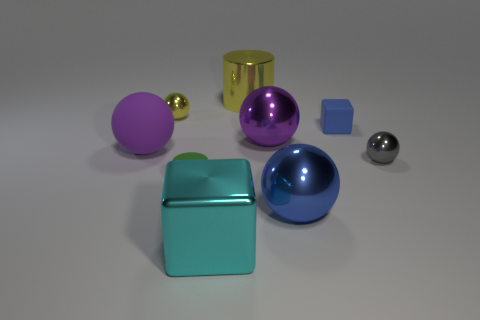There is a small ball that is in front of the purple thing right of the large yellow object; what is its color?
Provide a short and direct response. Gray. Is the number of matte cylinders behind the gray metallic object less than the number of large purple things that are to the right of the tiny green thing?
Offer a terse response. Yes. There is a blue block; is its size the same as the gray sphere that is behind the blue metallic sphere?
Provide a succinct answer. Yes. What is the shape of the metallic object that is behind the matte block and in front of the metal cylinder?
Keep it short and to the point. Sphere. There is a sphere that is made of the same material as the tiny cube; what size is it?
Keep it short and to the point. Large. There is a blue thing that is behind the tiny rubber cylinder; how many large objects are behind it?
Ensure brevity in your answer.  1. Is the object to the left of the tiny yellow sphere made of the same material as the tiny green cylinder?
Give a very brief answer. Yes. Is there any other thing that is the same material as the yellow sphere?
Make the answer very short. Yes. What is the size of the cylinder that is in front of the block behind the large purple matte sphere?
Offer a terse response. Small. What is the size of the metallic sphere that is behind the block right of the shiny ball in front of the matte cylinder?
Keep it short and to the point. Small. 